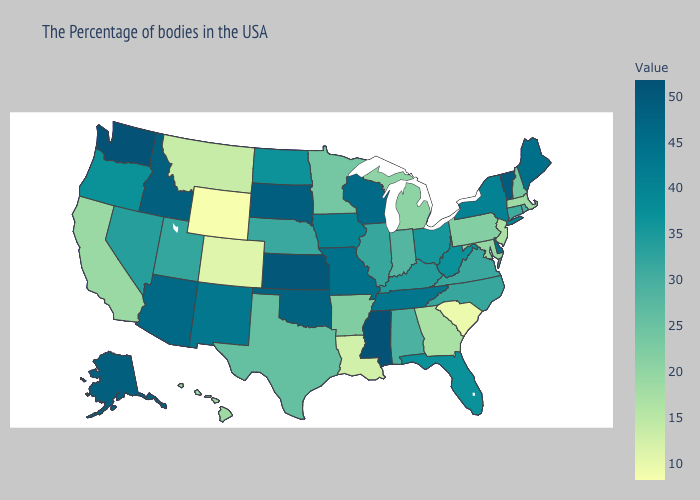Which states have the highest value in the USA?
Be succinct. Washington. Does Washington have the highest value in the USA?
Be succinct. Yes. Does Montana have the lowest value in the West?
Concise answer only. No. Does Wyoming have the lowest value in the USA?
Short answer required. Yes. Does Wyoming have the lowest value in the USA?
Quick response, please. Yes. Among the states that border North Carolina , which have the lowest value?
Answer briefly. South Carolina. Among the states that border Nebraska , which have the highest value?
Concise answer only. Kansas. 